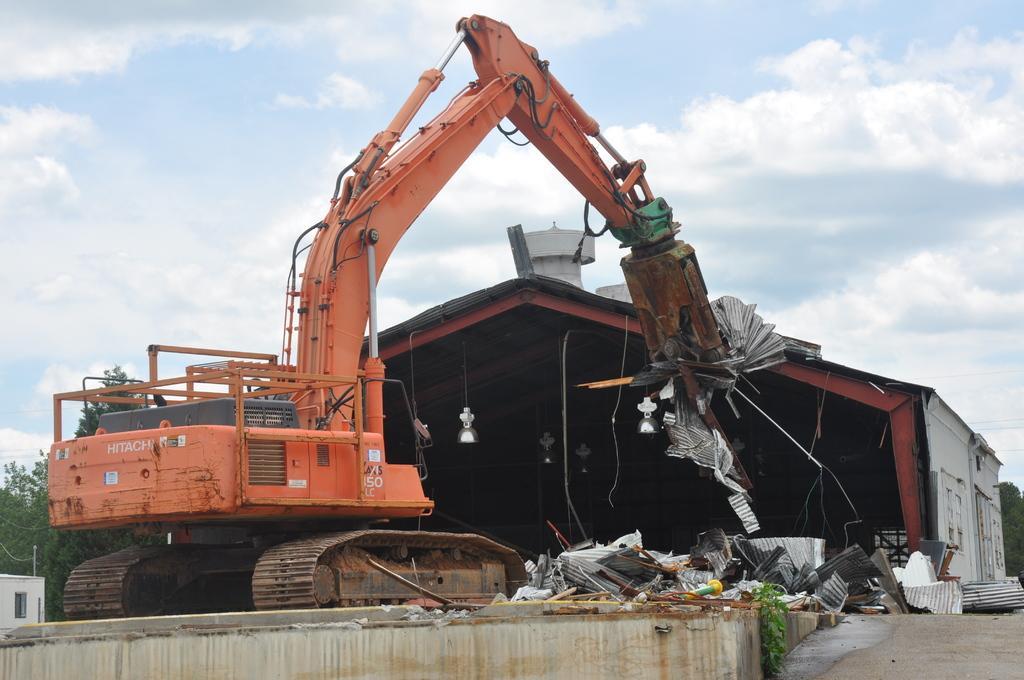Could you give a brief overview of what you see in this image? In this image there is a shed and vehicle in front of that. 